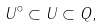Convert formula to latex. <formula><loc_0><loc_0><loc_500><loc_500>U ^ { \circ } \subset U \subset Q ,</formula> 